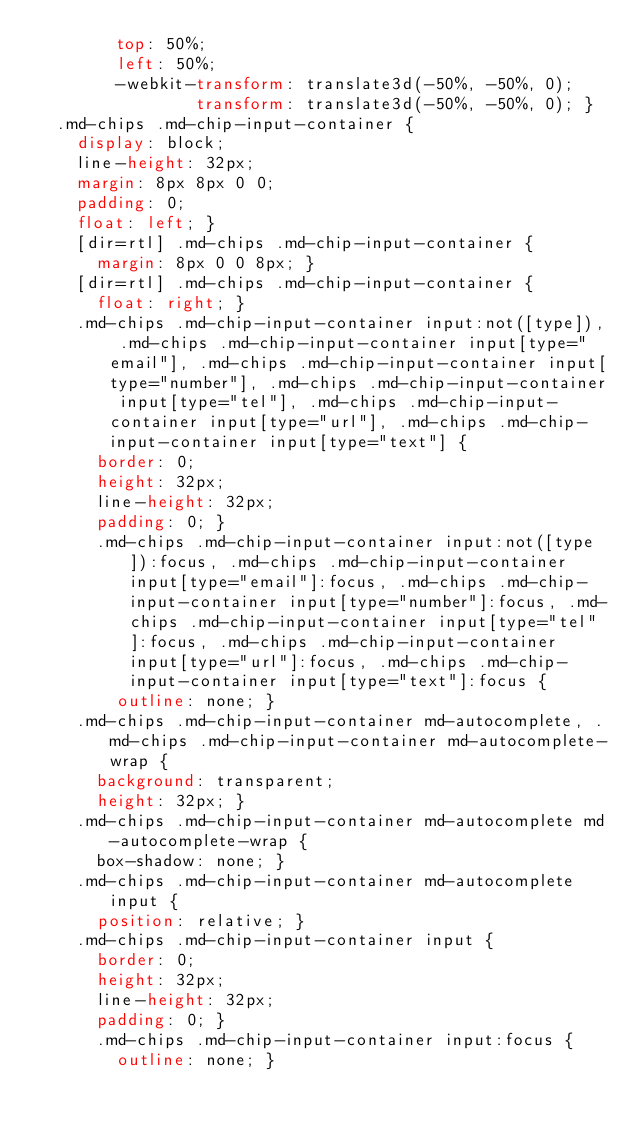Convert code to text. <code><loc_0><loc_0><loc_500><loc_500><_CSS_>        top: 50%;
        left: 50%;
        -webkit-transform: translate3d(-50%, -50%, 0);
                transform: translate3d(-50%, -50%, 0); }
  .md-chips .md-chip-input-container {
    display: block;
    line-height: 32px;
    margin: 8px 8px 0 0;
    padding: 0;
    float: left; }
    [dir=rtl] .md-chips .md-chip-input-container {
      margin: 8px 0 0 8px; }
    [dir=rtl] .md-chips .md-chip-input-container {
      float: right; }
    .md-chips .md-chip-input-container input:not([type]), .md-chips .md-chip-input-container input[type="email"], .md-chips .md-chip-input-container input[type="number"], .md-chips .md-chip-input-container input[type="tel"], .md-chips .md-chip-input-container input[type="url"], .md-chips .md-chip-input-container input[type="text"] {
      border: 0;
      height: 32px;
      line-height: 32px;
      padding: 0; }
      .md-chips .md-chip-input-container input:not([type]):focus, .md-chips .md-chip-input-container input[type="email"]:focus, .md-chips .md-chip-input-container input[type="number"]:focus, .md-chips .md-chip-input-container input[type="tel"]:focus, .md-chips .md-chip-input-container input[type="url"]:focus, .md-chips .md-chip-input-container input[type="text"]:focus {
        outline: none; }
    .md-chips .md-chip-input-container md-autocomplete, .md-chips .md-chip-input-container md-autocomplete-wrap {
      background: transparent;
      height: 32px; }
    .md-chips .md-chip-input-container md-autocomplete md-autocomplete-wrap {
      box-shadow: none; }
    .md-chips .md-chip-input-container md-autocomplete input {
      position: relative; }
    .md-chips .md-chip-input-container input {
      border: 0;
      height: 32px;
      line-height: 32px;
      padding: 0; }
      .md-chips .md-chip-input-container input:focus {
        outline: none; }</code> 